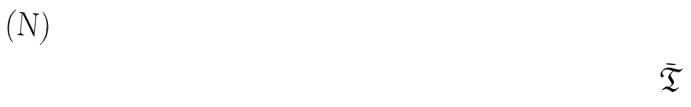<formula> <loc_0><loc_0><loc_500><loc_500>\bar { \mathfrak { T } }</formula> 